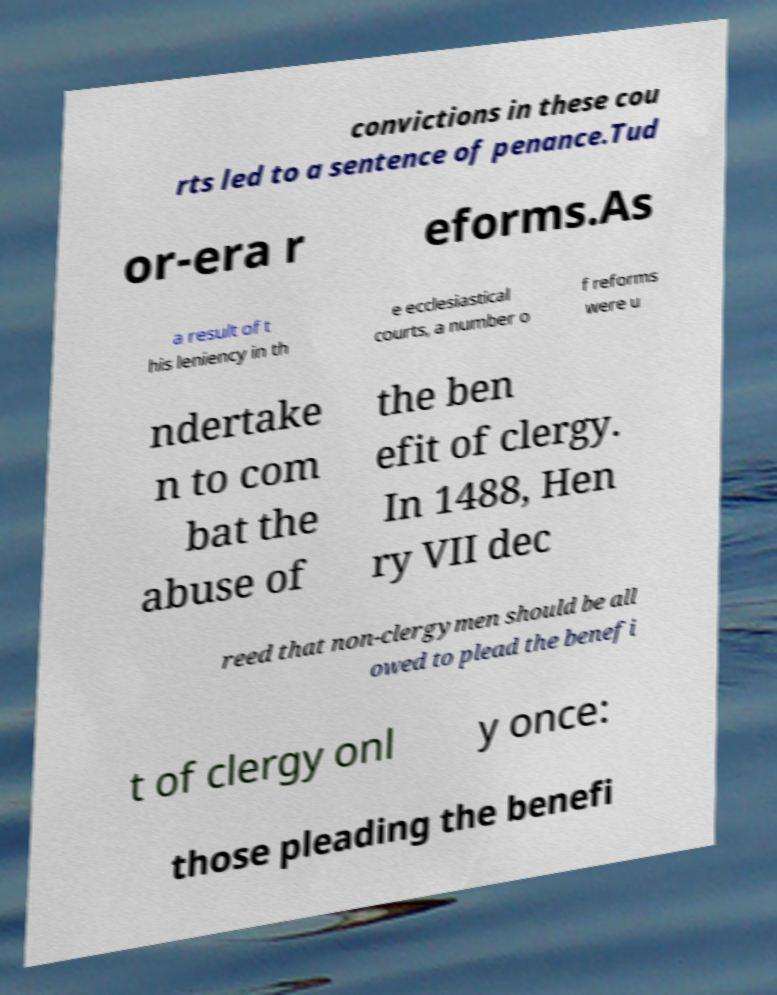Can you read and provide the text displayed in the image?This photo seems to have some interesting text. Can you extract and type it out for me? convictions in these cou rts led to a sentence of penance.Tud or-era r eforms.As a result of t his leniency in th e ecclesiastical courts, a number o f reforms were u ndertake n to com bat the abuse of the ben efit of clergy. In 1488, Hen ry VII dec reed that non-clergymen should be all owed to plead the benefi t of clergy onl y once: those pleading the benefi 